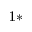Convert formula to latex. <formula><loc_0><loc_0><loc_500><loc_500>^ { 1 \ast }</formula> 